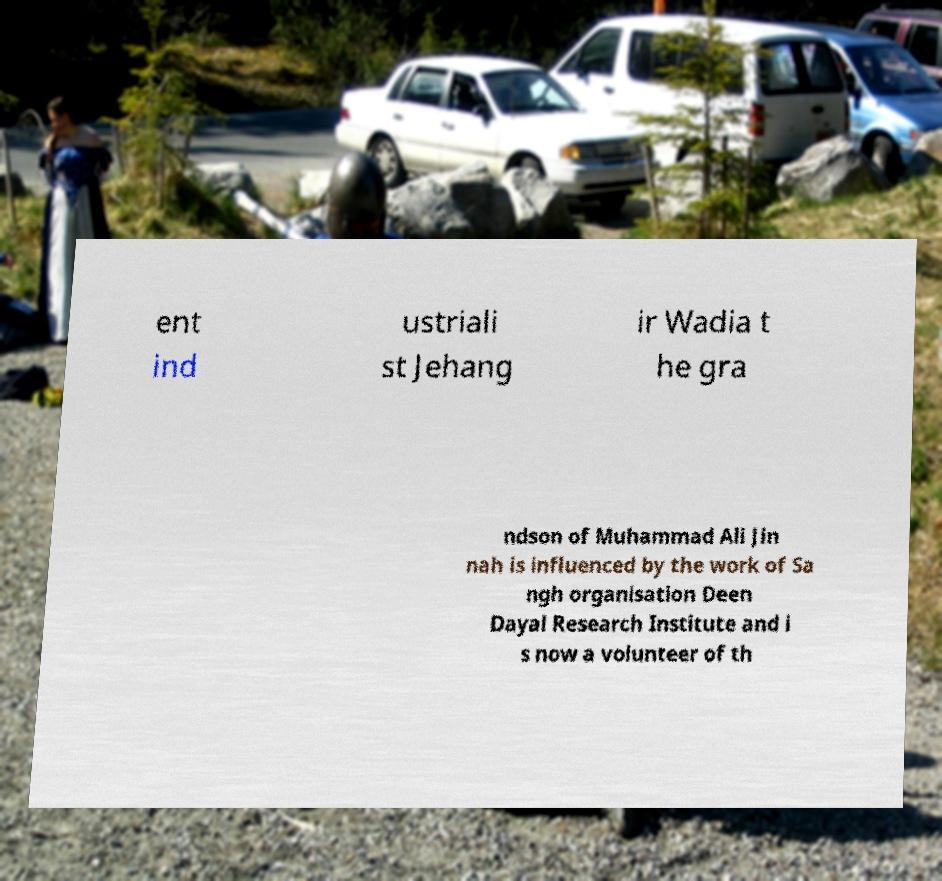Could you extract and type out the text from this image? ent ind ustriali st Jehang ir Wadia t he gra ndson of Muhammad Ali Jin nah is influenced by the work of Sa ngh organisation Deen Dayal Research Institute and i s now a volunteer of th 